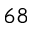<formula> <loc_0><loc_0><loc_500><loc_500>^ { 6 8 }</formula> 